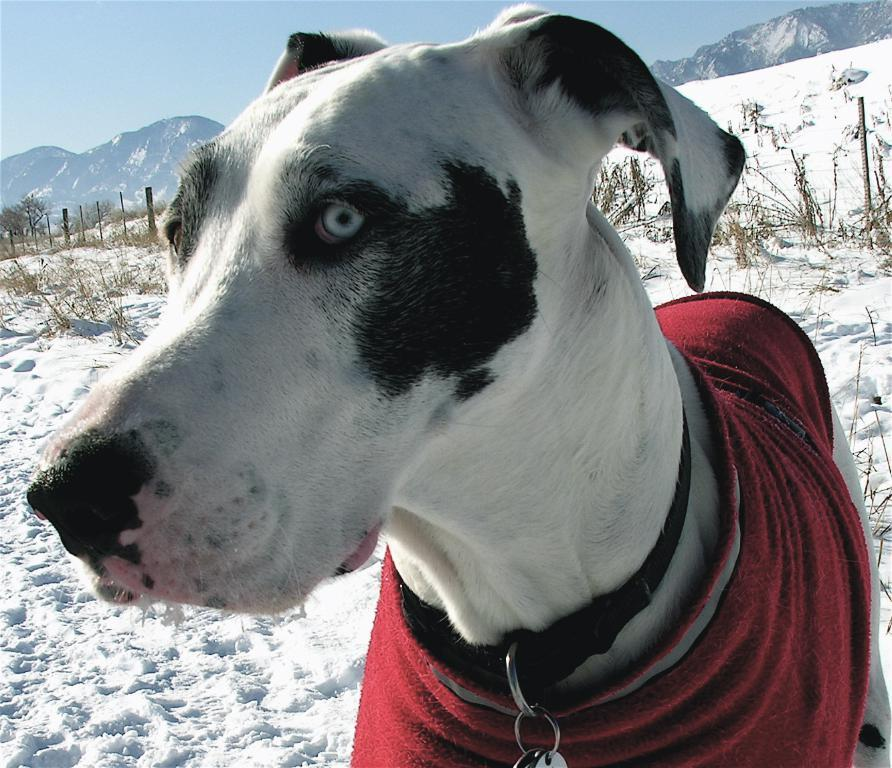What type of animal is in the image? There is a black and white dog in the image. What is the dog wearing around its neck? The dog has a belt around its neck. What type of terrain is the dog standing on? The dog is standing on land covered with ice. What type of vegetation is present on the land? Plants are present on the land. What structures are visible in the image? Poles are visible in the image. What type of geographical feature is visible in the distance? Mountains are visible in the image. What is the color of the sky in the image? The sky is blue. What type of flowers are growing on the dog's back in the image? There are no flowers present on the dog's back in the image; it is a black and white dog standing on ice. 